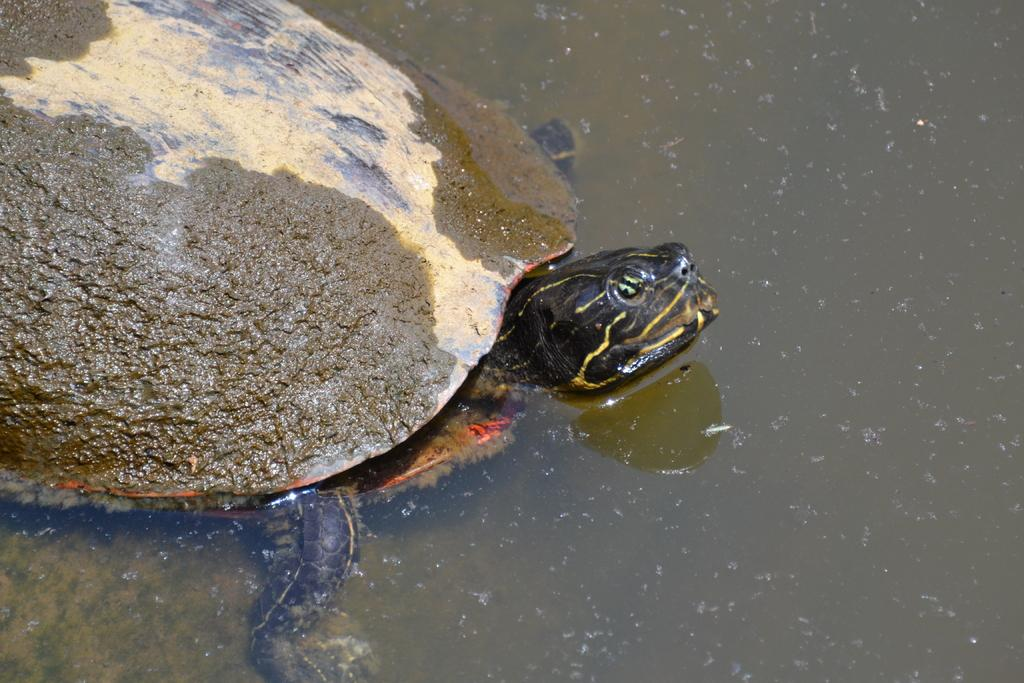What animal is present in the image? There is a tortoise in the image. Where is the tortoise located in the image? The tortoise is in the water. What type of cord is attached to the tortoise in the image? A: There is no cord attached to the tortoise in the image. 